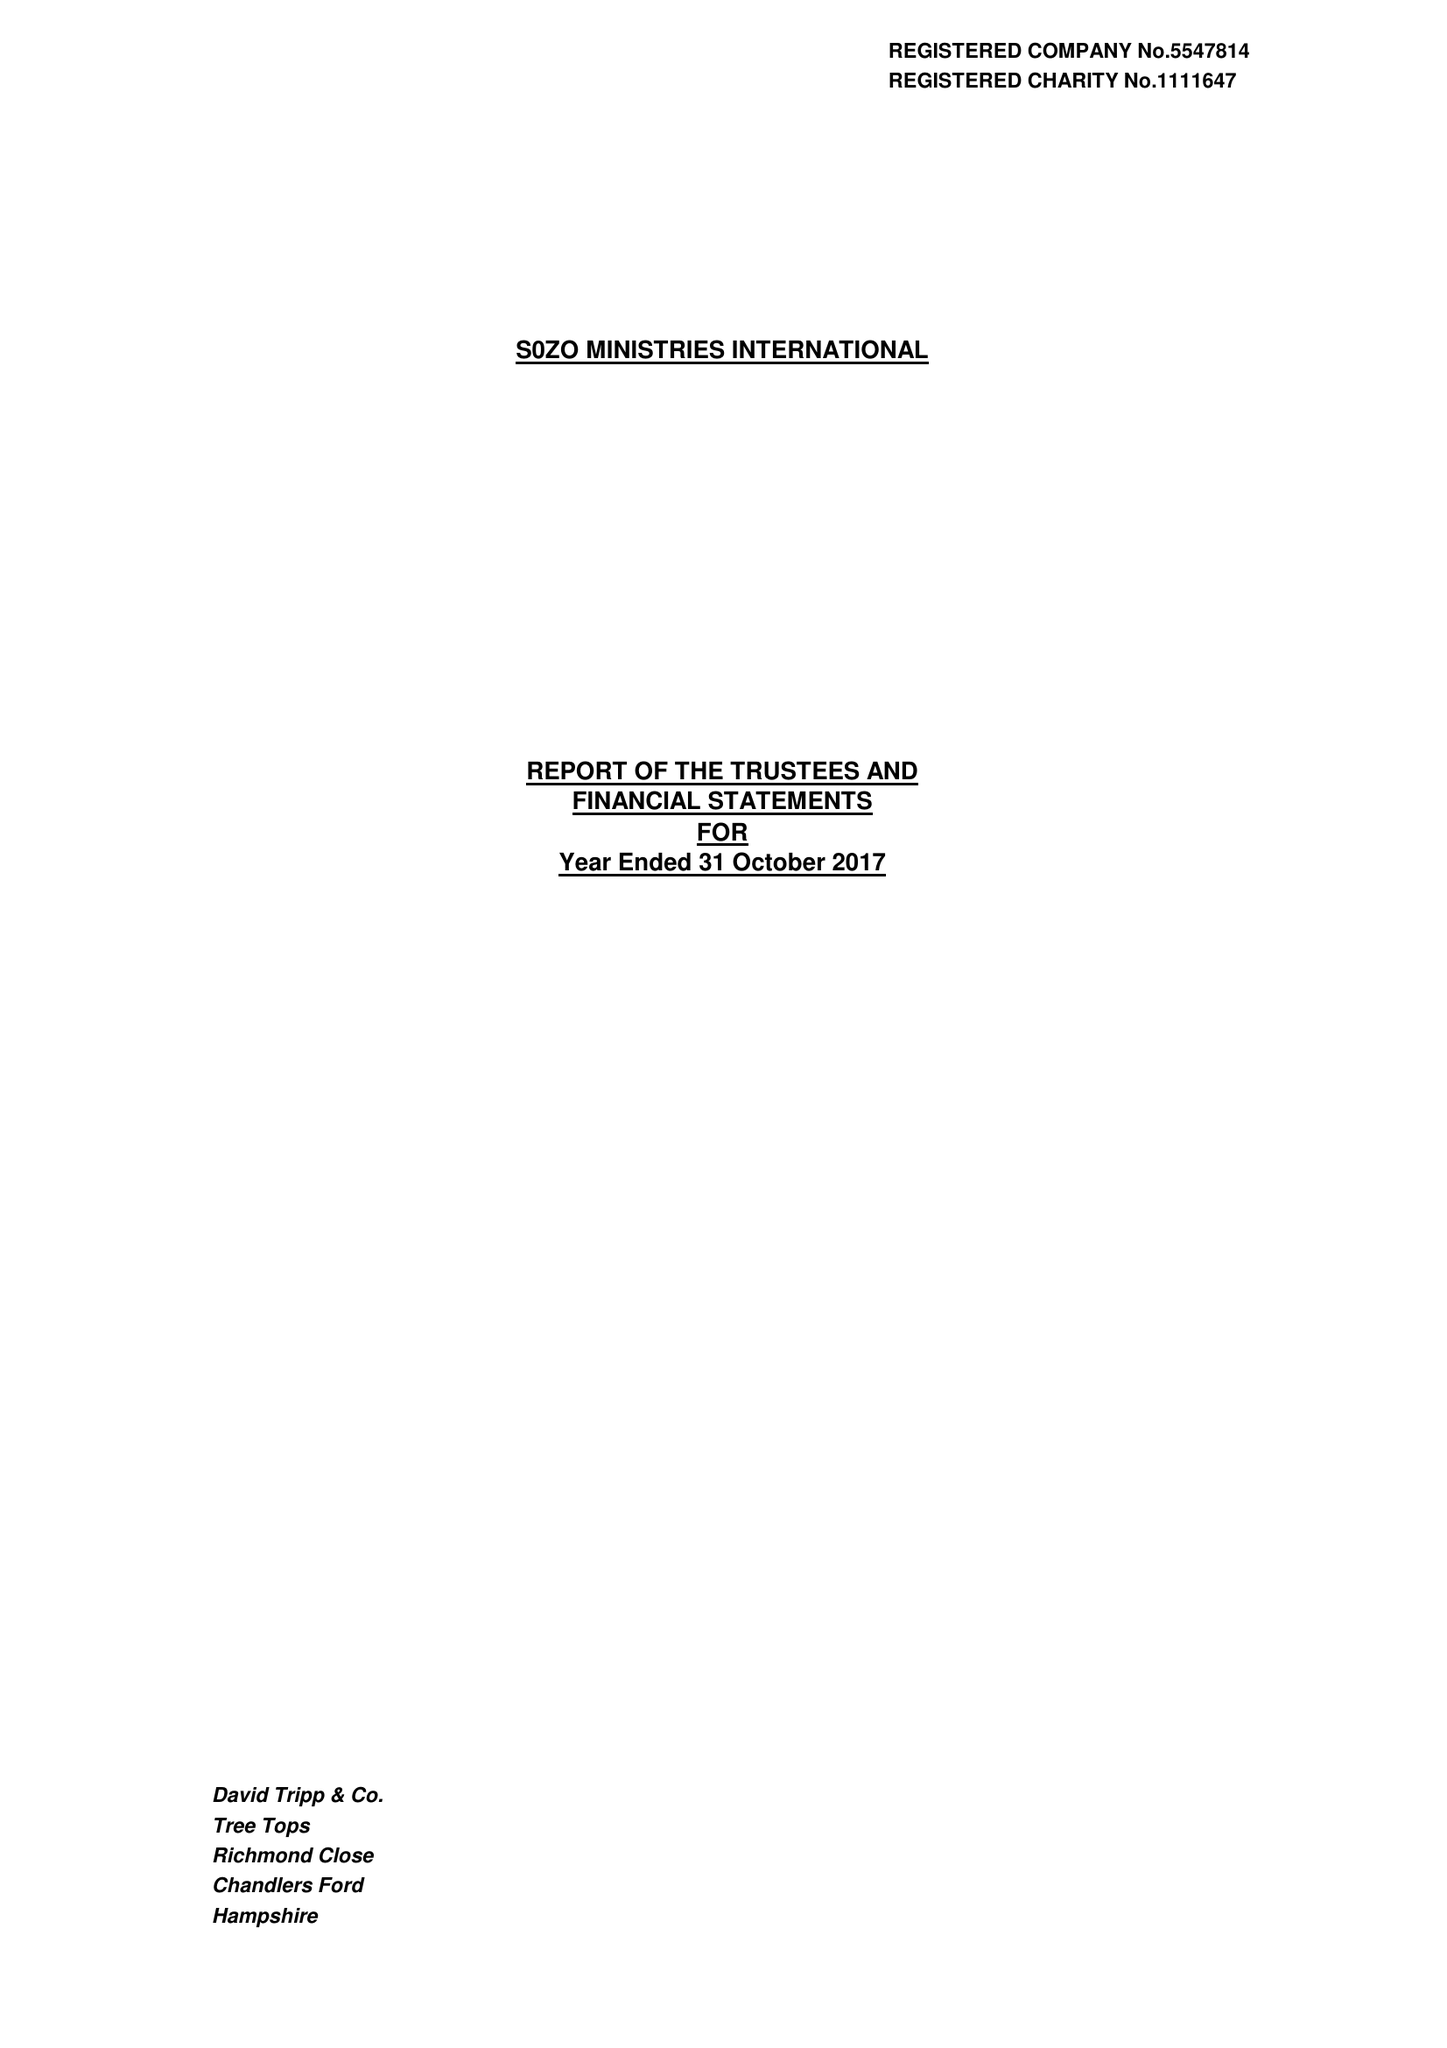What is the value for the charity_number?
Answer the question using a single word or phrase. 1111647 